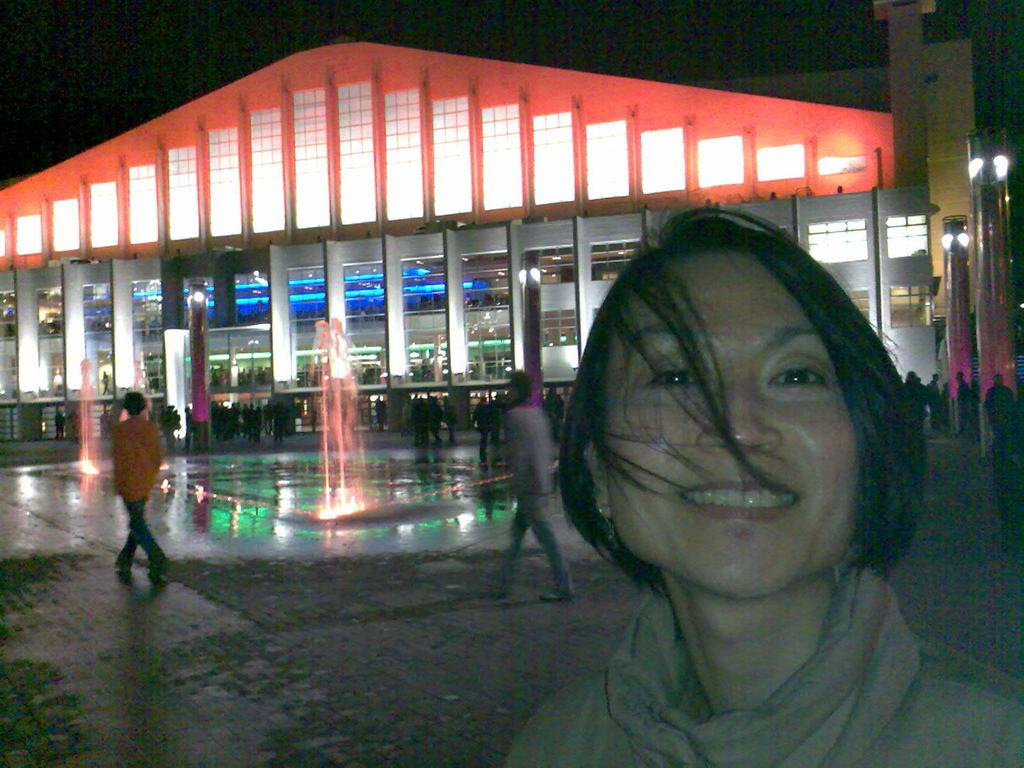Who is present in the image? There is a woman in the image. What is the woman's expression? The woman is smiling. What can be seen in the background of the image? There is a group of people, lights, water fountains, and a building visible in the background of the image. What type of camera is the woman using to take a picture of the balloon in the image? There is no camera or balloon present in the image. 